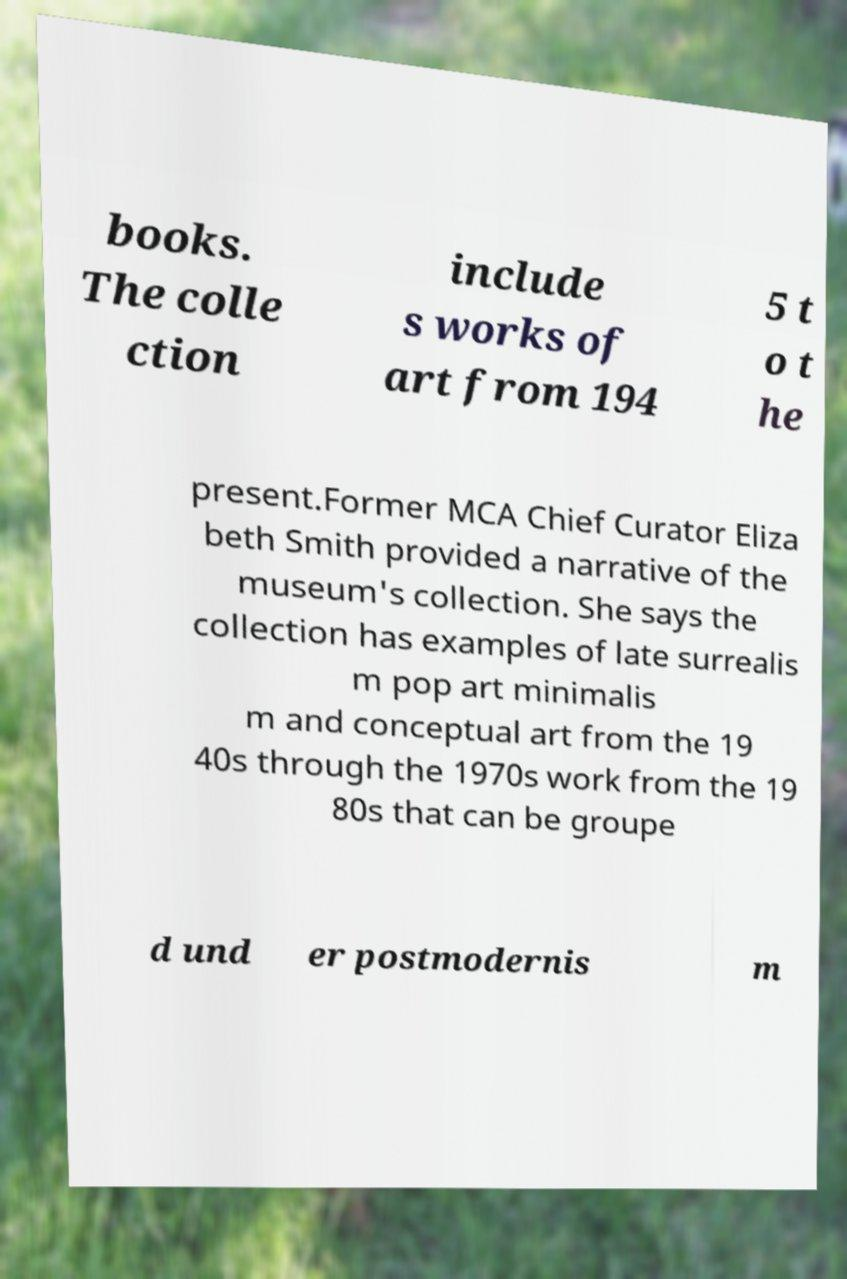Can you accurately transcribe the text from the provided image for me? books. The colle ction include s works of art from 194 5 t o t he present.Former MCA Chief Curator Eliza beth Smith provided a narrative of the museum's collection. She says the collection has examples of late surrealis m pop art minimalis m and conceptual art from the 19 40s through the 1970s work from the 19 80s that can be groupe d und er postmodernis m 